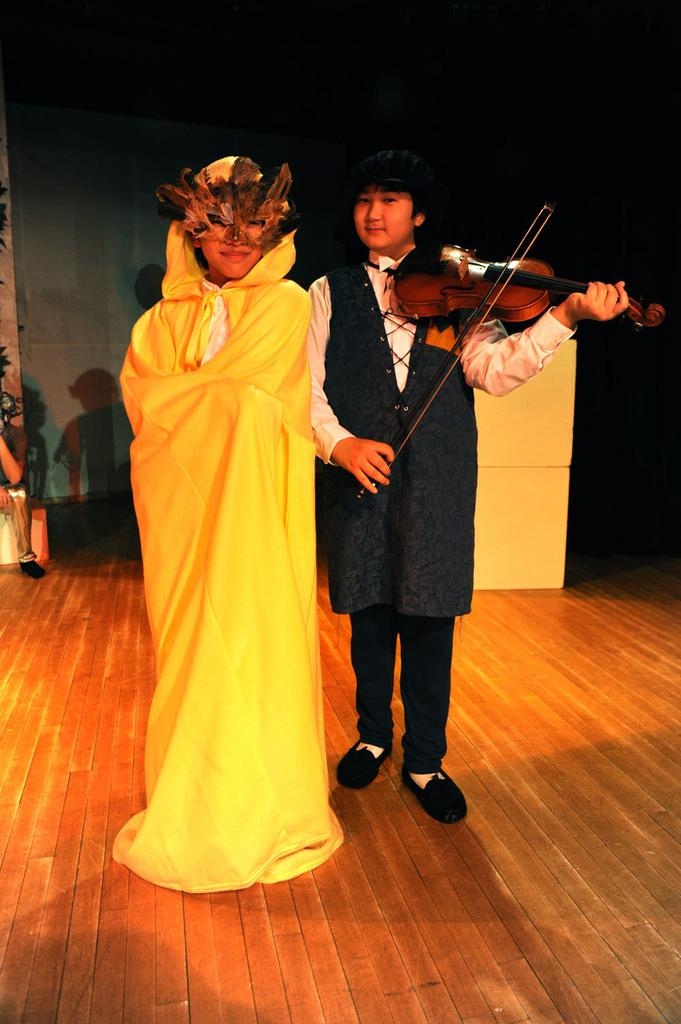How many people are present in the image? There are two people standing in the image. What is the appearance of one of the people? One person is wearing a yellow costume. What is the other person doing in the image? The other person is playing a violin. Can you describe the person in the background of the image? There is a person sitting in the background of the image. Where is the shelf with berries located in the image? There is no shelf or berries present in the image. What type of volleyball game is being played in the image? There is no volleyball game present in the image. 